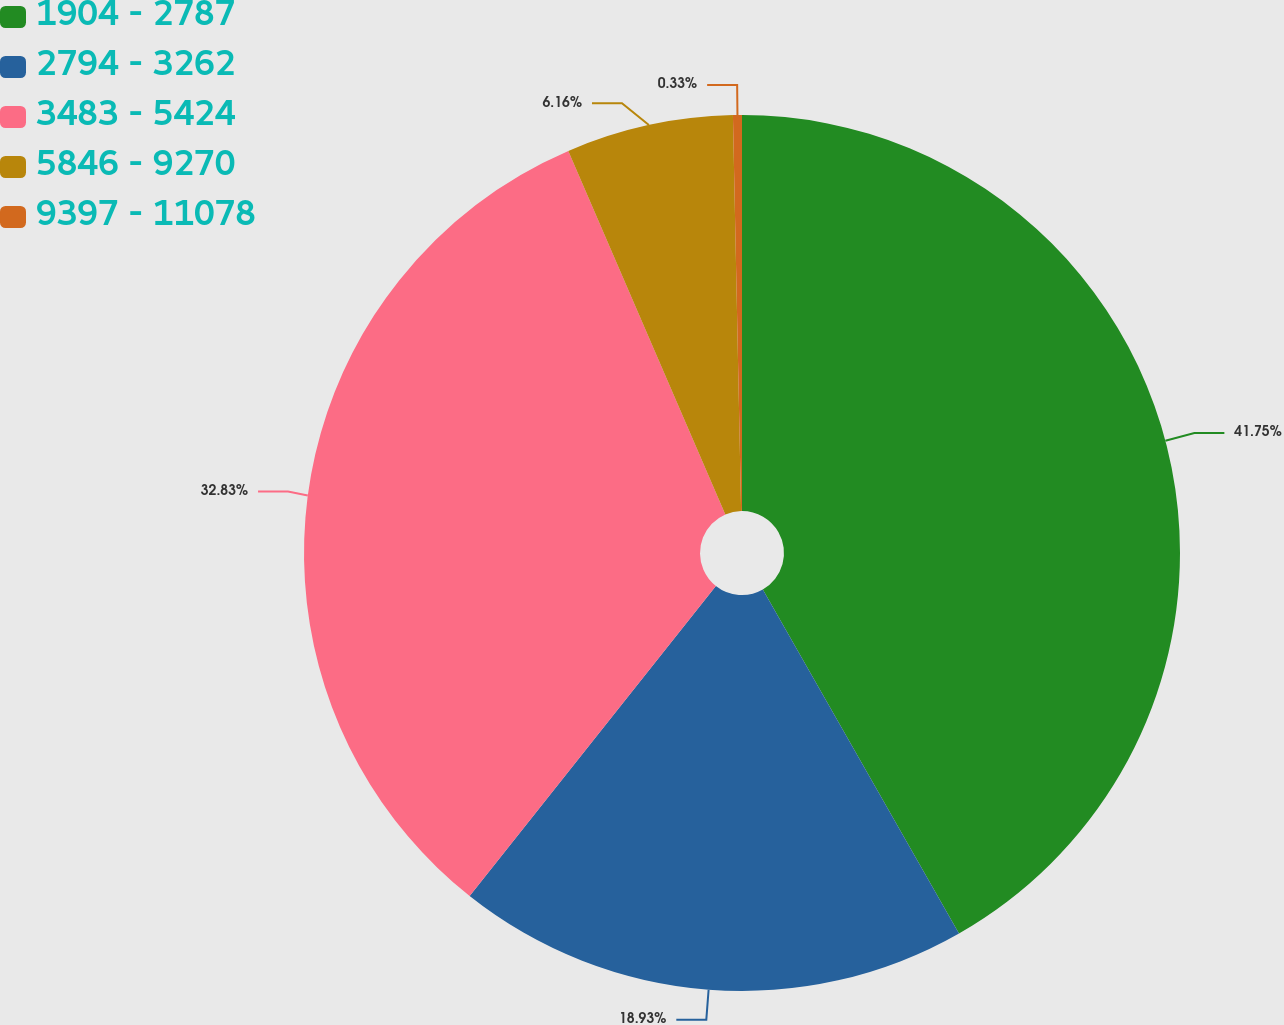Convert chart. <chart><loc_0><loc_0><loc_500><loc_500><pie_chart><fcel>1904 - 2787<fcel>2794 - 3262<fcel>3483 - 5424<fcel>5846 - 9270<fcel>9397 - 11078<nl><fcel>41.75%<fcel>18.93%<fcel>32.83%<fcel>6.16%<fcel>0.33%<nl></chart> 